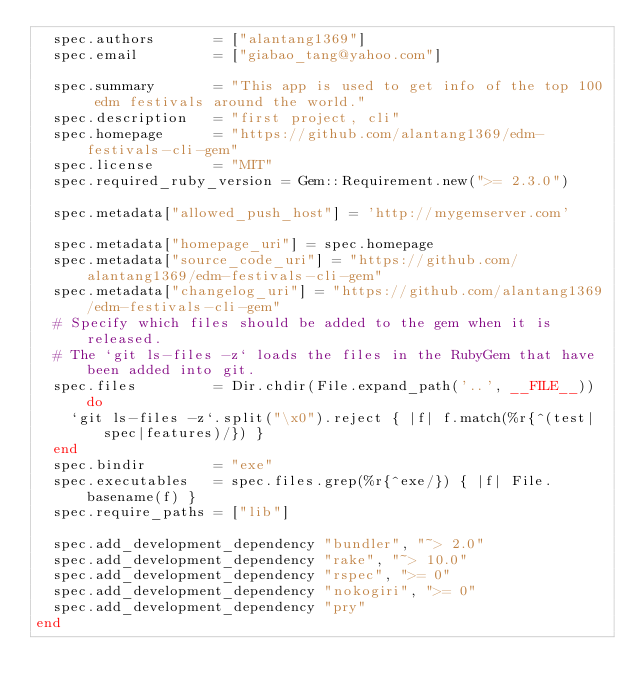<code> <loc_0><loc_0><loc_500><loc_500><_Ruby_>  spec.authors       = ["alantang1369"]
  spec.email         = ["giabao_tang@yahoo.com"]

  spec.summary       = "This app is used to get info of the top 100 edm festivals around the world."
  spec.description   = "first project, cli"
  spec.homepage      = "https://github.com/alantang1369/edm-festivals-cli-gem"
  spec.license       = "MIT"
  spec.required_ruby_version = Gem::Requirement.new(">= 2.3.0")

  spec.metadata["allowed_push_host"] = 'http://mygemserver.com'

  spec.metadata["homepage_uri"] = spec.homepage
  spec.metadata["source_code_uri"] = "https://github.com/alantang1369/edm-festivals-cli-gem"
  spec.metadata["changelog_uri"] = "https://github.com/alantang1369/edm-festivals-cli-gem"
  # Specify which files should be added to the gem when it is released.
  # The `git ls-files -z` loads the files in the RubyGem that have been added into git.
  spec.files         = Dir.chdir(File.expand_path('..', __FILE__)) do
    `git ls-files -z`.split("\x0").reject { |f| f.match(%r{^(test|spec|features)/}) }
  end
  spec.bindir        = "exe"
  spec.executables   = spec.files.grep(%r{^exe/}) { |f| File.basename(f) }
  spec.require_paths = ["lib"]

  spec.add_development_dependency "bundler", "~> 2.0"
  spec.add_development_dependency "rake", "~> 10.0"
  spec.add_development_dependency "rspec", ">= 0"
  spec.add_development_dependency "nokogiri", ">= 0"
  spec.add_development_dependency "pry"
end
</code> 